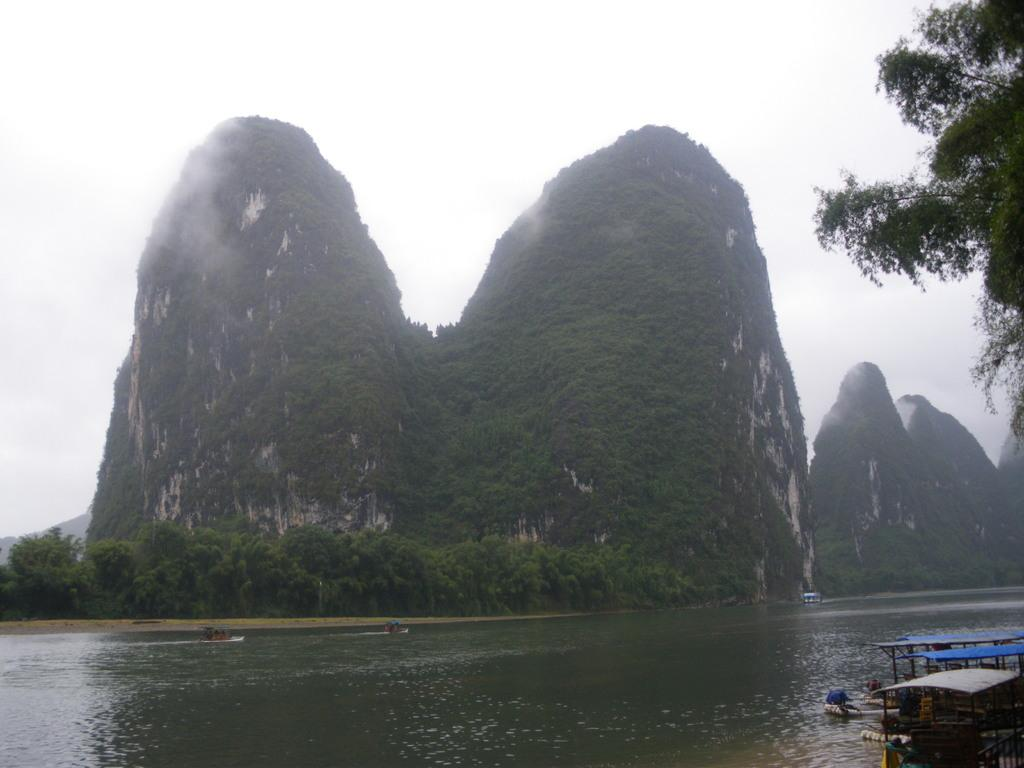What is in the foreground of the image? There is a water body in the foreground of the image. What is present in the water body? There are boats in the water body. What can be seen in the middle of the image? There are trees and hills in the middle of the image. What is visible at the top of the image? The sky is visible at the top of the image. What type of cheese is being used to build the hills in the image? There is no cheese present in the image; the hills are natural formations. How is the waste being managed in the water body in the image? There is no mention of waste management in the image; it only shows boats in the water body. 